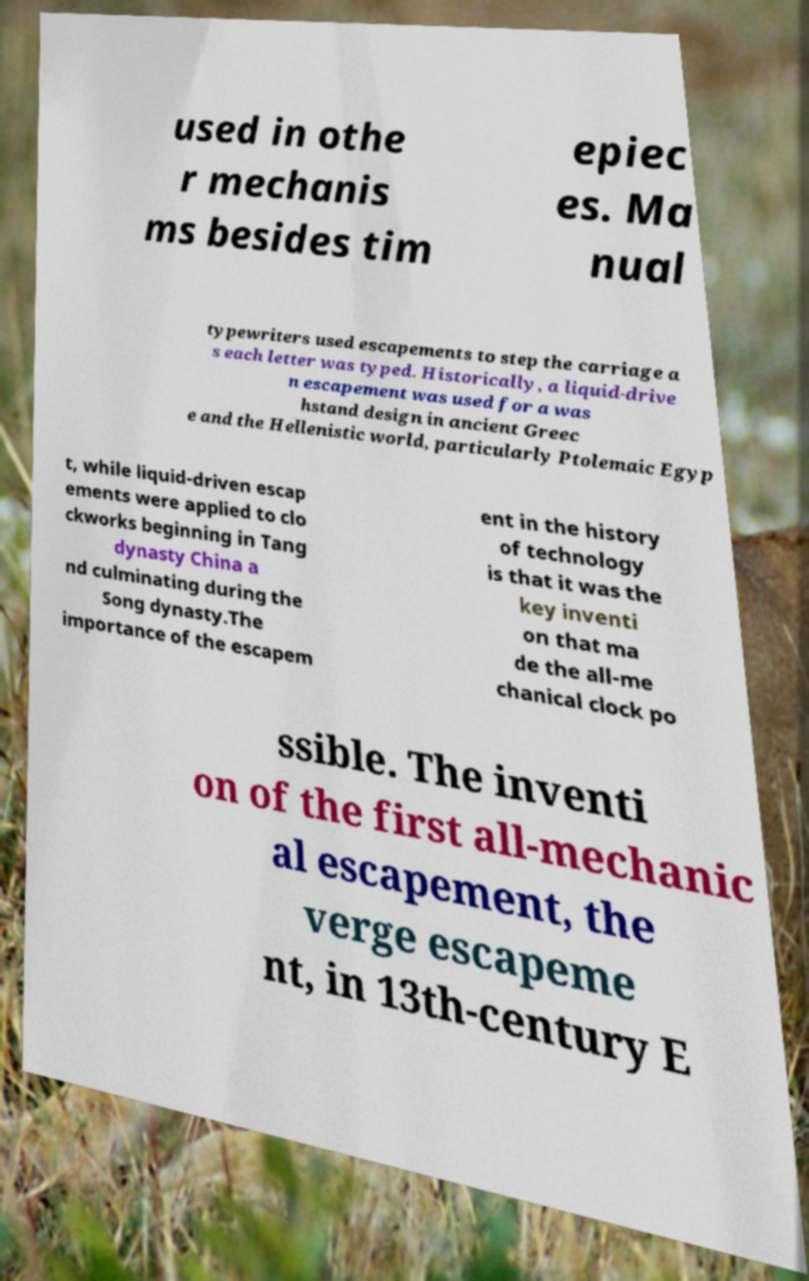Can you read and provide the text displayed in the image?This photo seems to have some interesting text. Can you extract and type it out for me? used in othe r mechanis ms besides tim epiec es. Ma nual typewriters used escapements to step the carriage a s each letter was typed. Historically, a liquid-drive n escapement was used for a was hstand design in ancient Greec e and the Hellenistic world, particularly Ptolemaic Egyp t, while liquid-driven escap ements were applied to clo ckworks beginning in Tang dynasty China a nd culminating during the Song dynasty.The importance of the escapem ent in the history of technology is that it was the key inventi on that ma de the all-me chanical clock po ssible. The inventi on of the first all-mechanic al escapement, the verge escapeme nt, in 13th-century E 